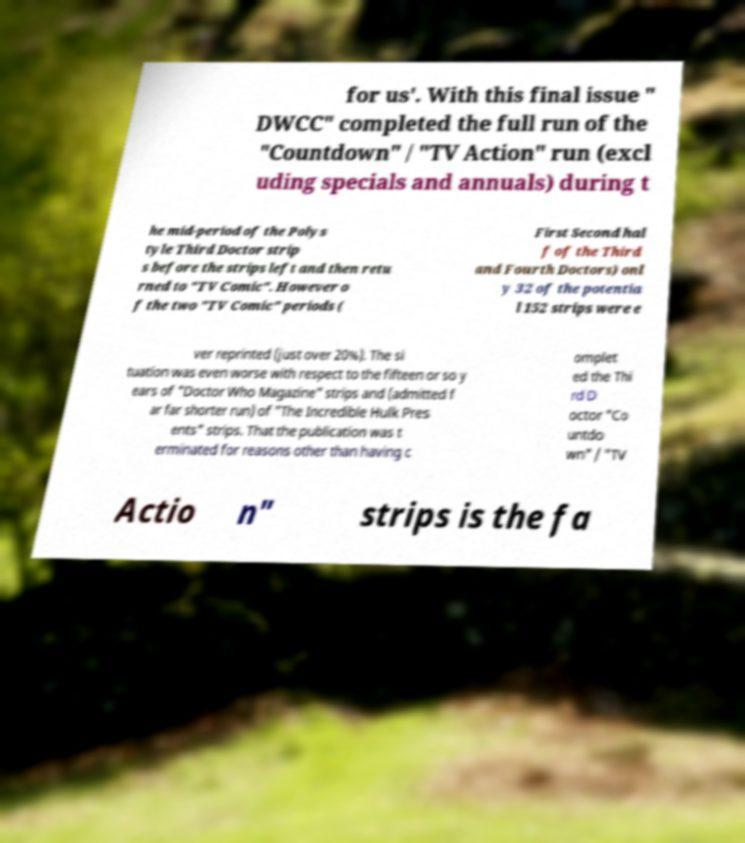There's text embedded in this image that I need extracted. Can you transcribe it verbatim? for us'. With this final issue " DWCC" completed the full run of the "Countdown" / "TV Action" run (excl uding specials and annuals) during t he mid-period of the Polys tyle Third Doctor strip s before the strips left and then retu rned to "TV Comic". However o f the two "TV Comic" periods ( First Second hal f of the Third and Fourth Doctors) onl y 32 of the potentia l 152 strips were e ver reprinted (just over 20%). The si tuation was even worse with respect to the fifteen or so y ears of "Doctor Who Magazine" strips and (admitted f ar far shorter run) of "The Incredible Hulk Pres ents" strips. That the publication was t erminated for reasons other than having c omplet ed the Thi rd D octor "Co untdo wn" / "TV Actio n" strips is the fa 